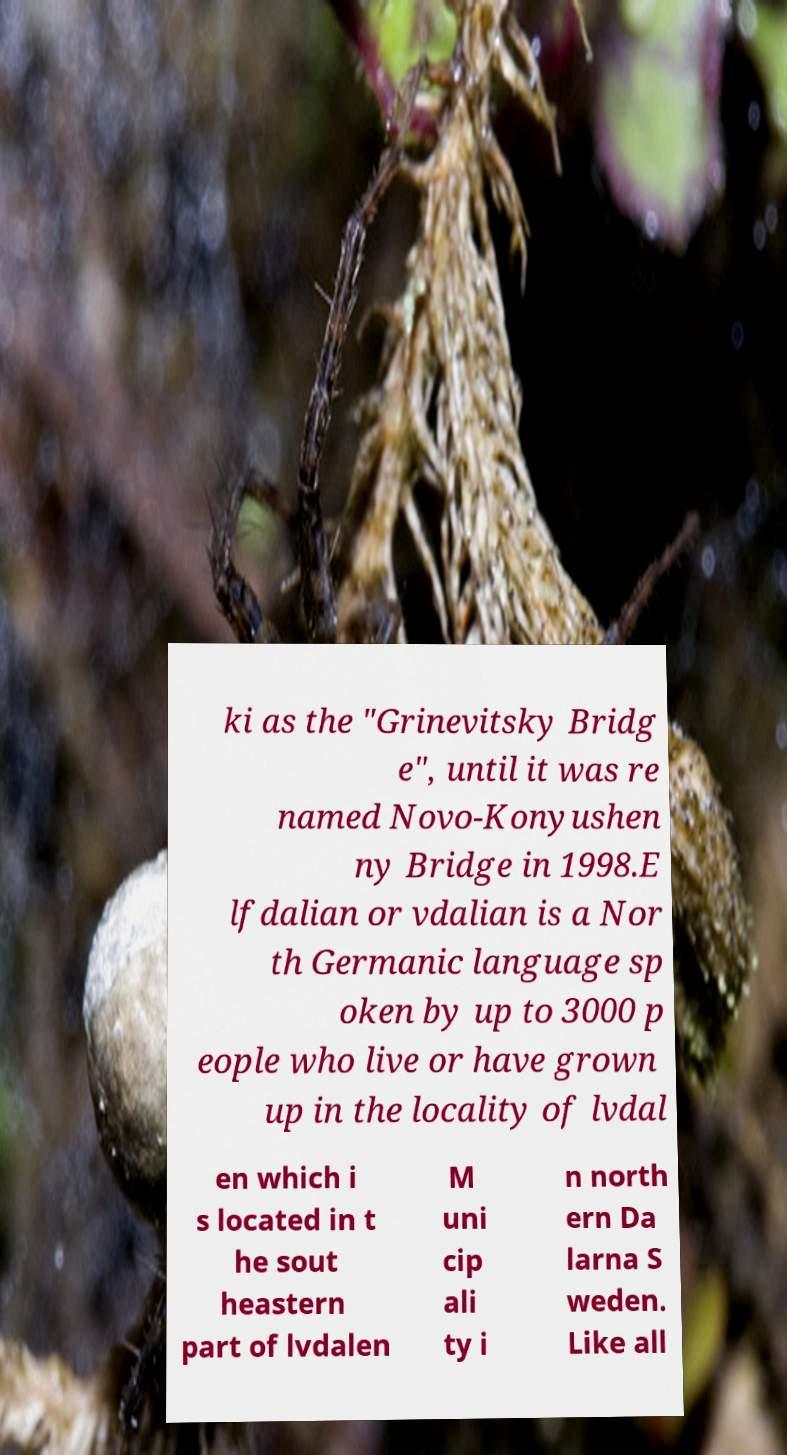Can you accurately transcribe the text from the provided image for me? ki as the "Grinevitsky Bridg e", until it was re named Novo-Konyushen ny Bridge in 1998.E lfdalian or vdalian is a Nor th Germanic language sp oken by up to 3000 p eople who live or have grown up in the locality of lvdal en which i s located in t he sout heastern part of lvdalen M uni cip ali ty i n north ern Da larna S weden. Like all 